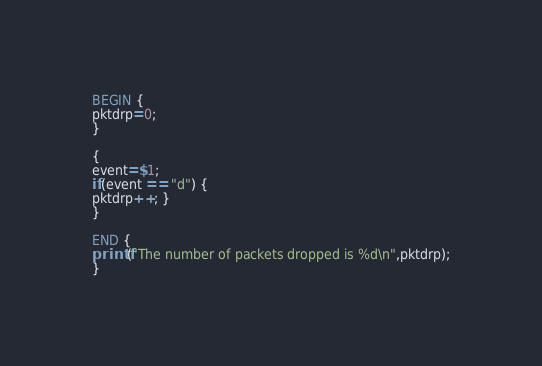Convert code to text. <code><loc_0><loc_0><loc_500><loc_500><_Awk_>BEGIN {
pktdrp=0;
}

{
event=$1;
if(event == "d") {
pktdrp++; }
}

END {
printf("The number of packets dropped is %d\n",pktdrp);
}
</code> 